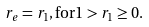Convert formula to latex. <formula><loc_0><loc_0><loc_500><loc_500>r _ { e } & = r _ { 1 } , \text {for} 1 > r _ { 1 } \geq 0 .</formula> 